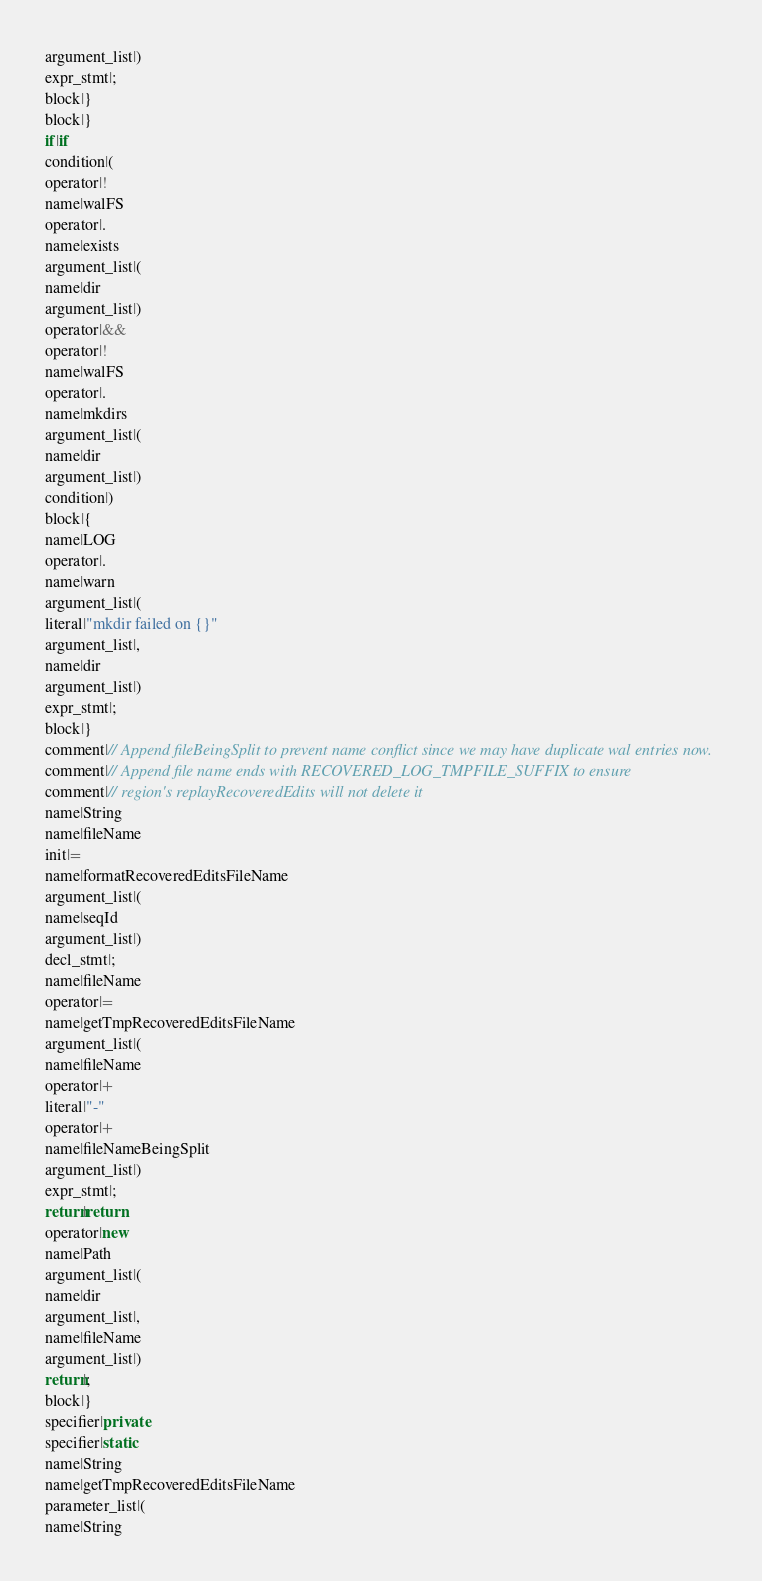Convert code to text. <code><loc_0><loc_0><loc_500><loc_500><_Java_>argument_list|)
expr_stmt|;
block|}
block|}
if|if
condition|(
operator|!
name|walFS
operator|.
name|exists
argument_list|(
name|dir
argument_list|)
operator|&&
operator|!
name|walFS
operator|.
name|mkdirs
argument_list|(
name|dir
argument_list|)
condition|)
block|{
name|LOG
operator|.
name|warn
argument_list|(
literal|"mkdir failed on {}"
argument_list|,
name|dir
argument_list|)
expr_stmt|;
block|}
comment|// Append fileBeingSplit to prevent name conflict since we may have duplicate wal entries now.
comment|// Append file name ends with RECOVERED_LOG_TMPFILE_SUFFIX to ensure
comment|// region's replayRecoveredEdits will not delete it
name|String
name|fileName
init|=
name|formatRecoveredEditsFileName
argument_list|(
name|seqId
argument_list|)
decl_stmt|;
name|fileName
operator|=
name|getTmpRecoveredEditsFileName
argument_list|(
name|fileName
operator|+
literal|"-"
operator|+
name|fileNameBeingSplit
argument_list|)
expr_stmt|;
return|return
operator|new
name|Path
argument_list|(
name|dir
argument_list|,
name|fileName
argument_list|)
return|;
block|}
specifier|private
specifier|static
name|String
name|getTmpRecoveredEditsFileName
parameter_list|(
name|String</code> 